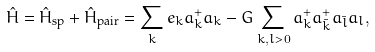<formula> <loc_0><loc_0><loc_500><loc_500>\hat { H } = \hat { H } _ { \text {sp} } + \hat { H } _ { \text {pair} } = \sum _ { k } e _ { k } a ^ { + } _ { k } a _ { k } - G \sum _ { k , l > 0 } a ^ { + } _ { k } a ^ { + } _ { \bar { k } } a _ { \bar { l } } a _ { l } ,</formula> 